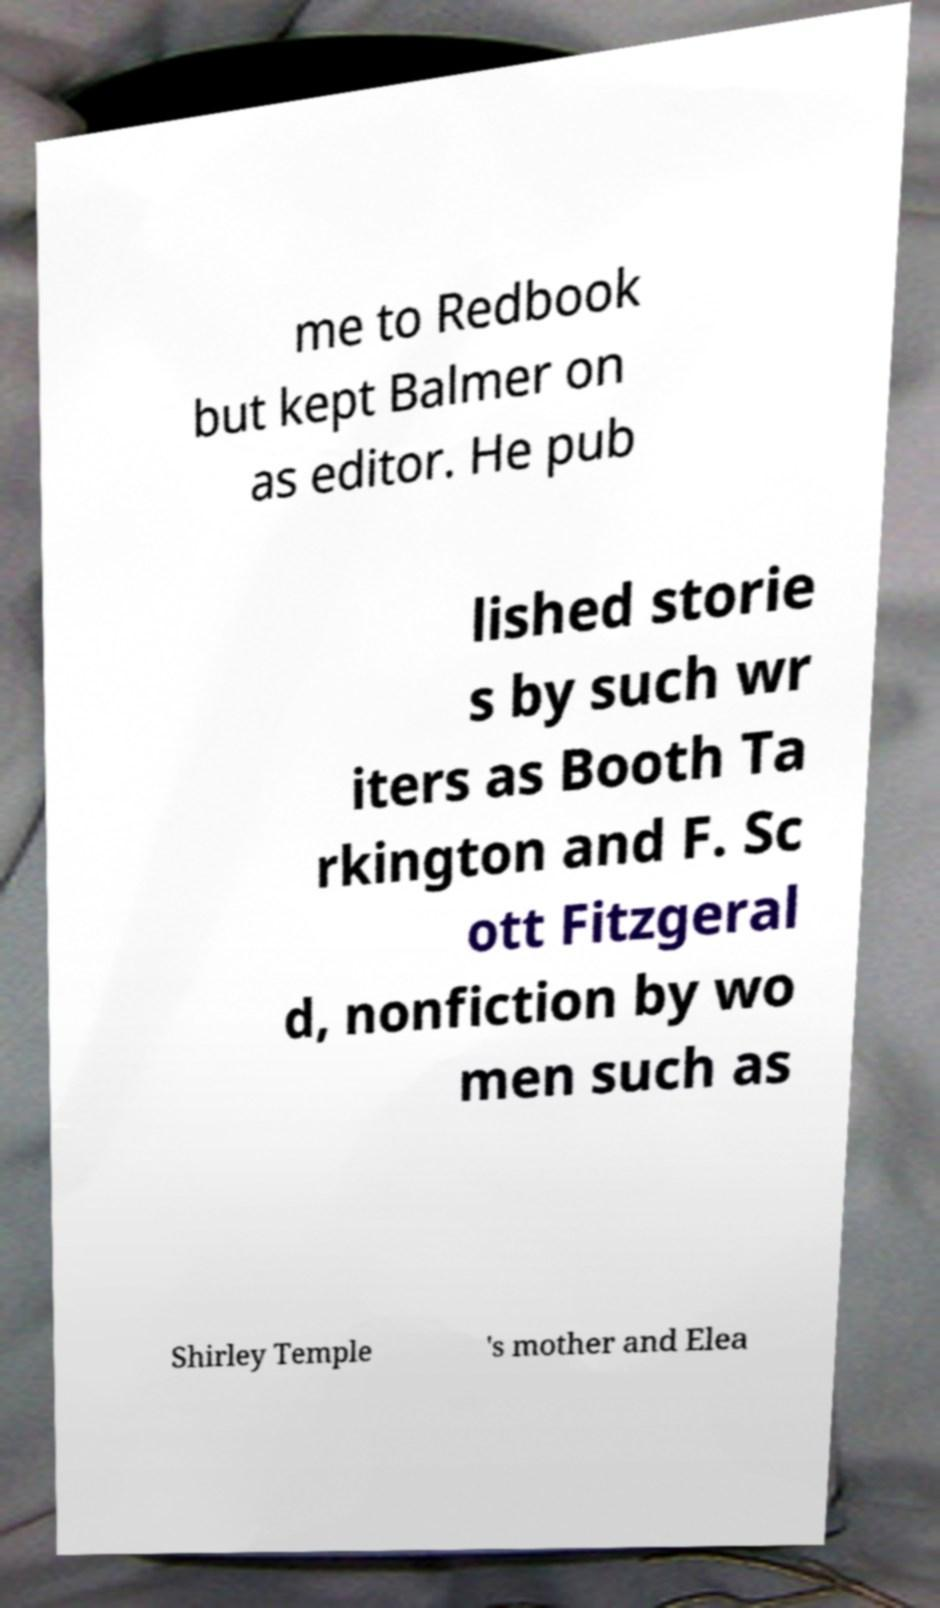Please identify and transcribe the text found in this image. me to Redbook but kept Balmer on as editor. He pub lished storie s by such wr iters as Booth Ta rkington and F. Sc ott Fitzgeral d, nonfiction by wo men such as Shirley Temple 's mother and Elea 